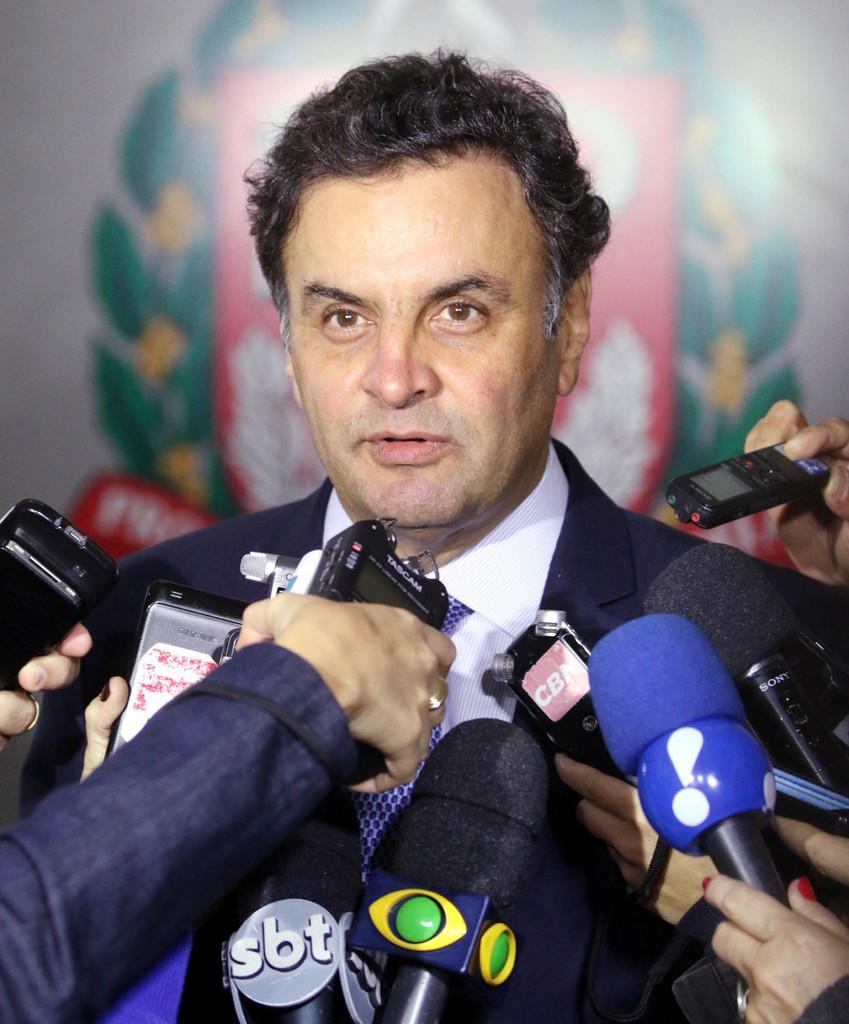Could you give a brief overview of what you see in this image? In this image there is a man in the middle. In front of him there are persons who are holding the mics. In the background there is a banner. 